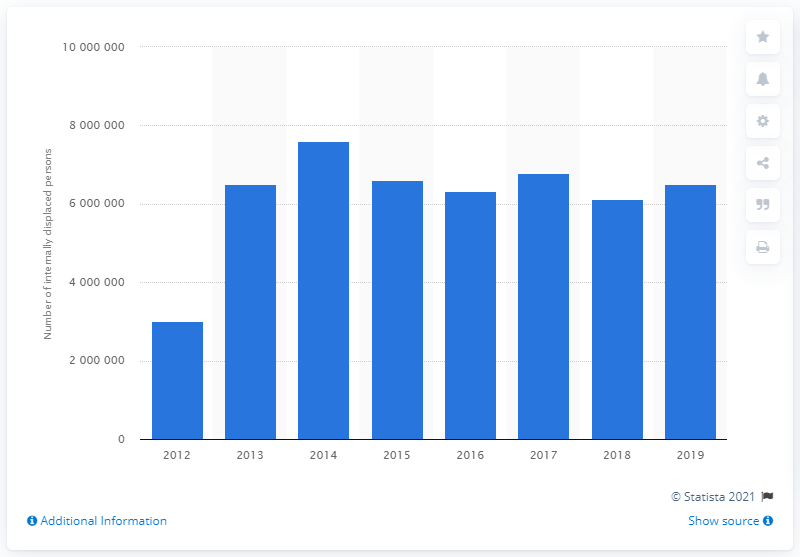Identify some key points in this picture. In 2019, the United Nations registered a significant number of internally displaced persons in Syria, with a total of 649,5000 individuals. 